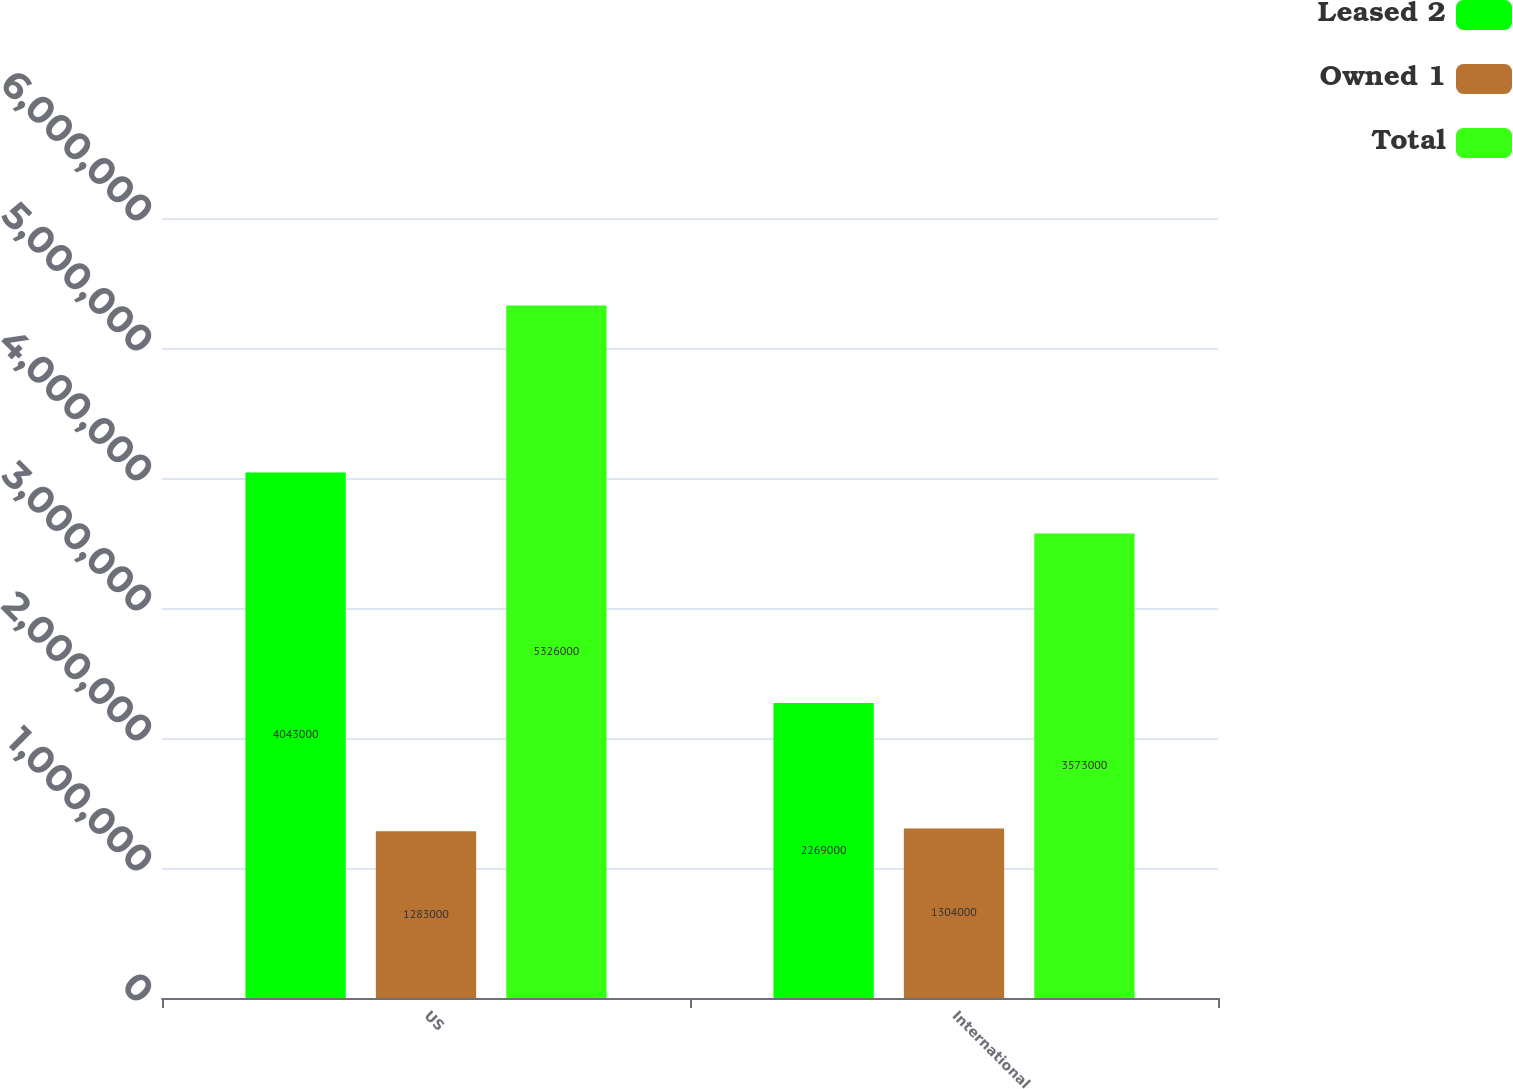Convert chart. <chart><loc_0><loc_0><loc_500><loc_500><stacked_bar_chart><ecel><fcel>US<fcel>International<nl><fcel>Leased 2<fcel>4.043e+06<fcel>2.269e+06<nl><fcel>Owned 1<fcel>1.283e+06<fcel>1.304e+06<nl><fcel>Total<fcel>5.326e+06<fcel>3.573e+06<nl></chart> 